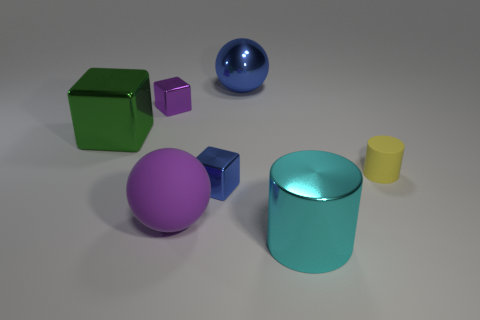What emotions do the colors in the image evoke? Color psychology suggests that each color can evoke certain emotions. The green cube might be seen as refreshing or natural, the blue sphere as calm or trustworthy, the yellow cylinder as cheerful or energetic, the cyan cylinder as clean and cool, and the purple shapes as royal or mysterious. The use of these colors, in this minimalist setting, can induce feelings tied to these emotional associations. 